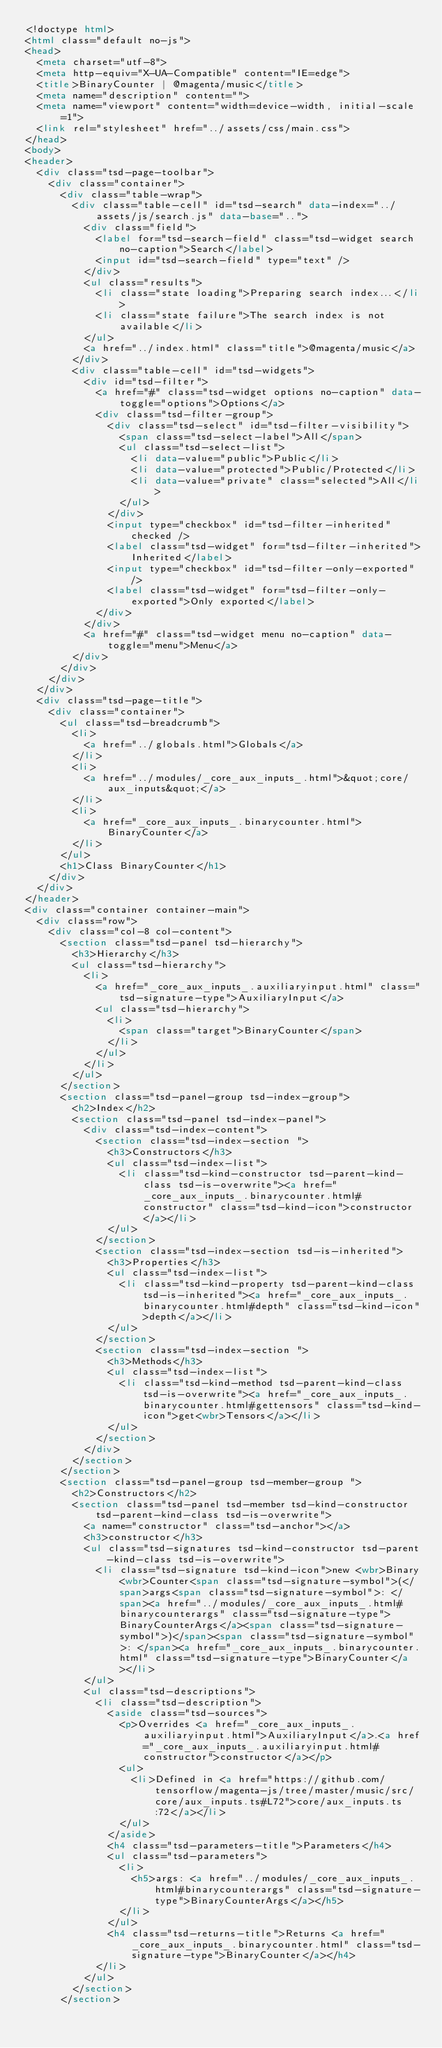Convert code to text. <code><loc_0><loc_0><loc_500><loc_500><_HTML_><!doctype html>
<html class="default no-js">
<head>
	<meta charset="utf-8">
	<meta http-equiv="X-UA-Compatible" content="IE=edge">
	<title>BinaryCounter | @magenta/music</title>
	<meta name="description" content="">
	<meta name="viewport" content="width=device-width, initial-scale=1">
	<link rel="stylesheet" href="../assets/css/main.css">
</head>
<body>
<header>
	<div class="tsd-page-toolbar">
		<div class="container">
			<div class="table-wrap">
				<div class="table-cell" id="tsd-search" data-index="../assets/js/search.js" data-base="..">
					<div class="field">
						<label for="tsd-search-field" class="tsd-widget search no-caption">Search</label>
						<input id="tsd-search-field" type="text" />
					</div>
					<ul class="results">
						<li class="state loading">Preparing search index...</li>
						<li class="state failure">The search index is not available</li>
					</ul>
					<a href="../index.html" class="title">@magenta/music</a>
				</div>
				<div class="table-cell" id="tsd-widgets">
					<div id="tsd-filter">
						<a href="#" class="tsd-widget options no-caption" data-toggle="options">Options</a>
						<div class="tsd-filter-group">
							<div class="tsd-select" id="tsd-filter-visibility">
								<span class="tsd-select-label">All</span>
								<ul class="tsd-select-list">
									<li data-value="public">Public</li>
									<li data-value="protected">Public/Protected</li>
									<li data-value="private" class="selected">All</li>
								</ul>
							</div>
							<input type="checkbox" id="tsd-filter-inherited" checked />
							<label class="tsd-widget" for="tsd-filter-inherited">Inherited</label>
							<input type="checkbox" id="tsd-filter-only-exported" />
							<label class="tsd-widget" for="tsd-filter-only-exported">Only exported</label>
						</div>
					</div>
					<a href="#" class="tsd-widget menu no-caption" data-toggle="menu">Menu</a>
				</div>
			</div>
		</div>
	</div>
	<div class="tsd-page-title">
		<div class="container">
			<ul class="tsd-breadcrumb">
				<li>
					<a href="../globals.html">Globals</a>
				</li>
				<li>
					<a href="../modules/_core_aux_inputs_.html">&quot;core/aux_inputs&quot;</a>
				</li>
				<li>
					<a href="_core_aux_inputs_.binarycounter.html">BinaryCounter</a>
				</li>
			</ul>
			<h1>Class BinaryCounter</h1>
		</div>
	</div>
</header>
<div class="container container-main">
	<div class="row">
		<div class="col-8 col-content">
			<section class="tsd-panel tsd-hierarchy">
				<h3>Hierarchy</h3>
				<ul class="tsd-hierarchy">
					<li>
						<a href="_core_aux_inputs_.auxiliaryinput.html" class="tsd-signature-type">AuxiliaryInput</a>
						<ul class="tsd-hierarchy">
							<li>
								<span class="target">BinaryCounter</span>
							</li>
						</ul>
					</li>
				</ul>
			</section>
			<section class="tsd-panel-group tsd-index-group">
				<h2>Index</h2>
				<section class="tsd-panel tsd-index-panel">
					<div class="tsd-index-content">
						<section class="tsd-index-section ">
							<h3>Constructors</h3>
							<ul class="tsd-index-list">
								<li class="tsd-kind-constructor tsd-parent-kind-class tsd-is-overwrite"><a href="_core_aux_inputs_.binarycounter.html#constructor" class="tsd-kind-icon">constructor</a></li>
							</ul>
						</section>
						<section class="tsd-index-section tsd-is-inherited">
							<h3>Properties</h3>
							<ul class="tsd-index-list">
								<li class="tsd-kind-property tsd-parent-kind-class tsd-is-inherited"><a href="_core_aux_inputs_.binarycounter.html#depth" class="tsd-kind-icon">depth</a></li>
							</ul>
						</section>
						<section class="tsd-index-section ">
							<h3>Methods</h3>
							<ul class="tsd-index-list">
								<li class="tsd-kind-method tsd-parent-kind-class tsd-is-overwrite"><a href="_core_aux_inputs_.binarycounter.html#gettensors" class="tsd-kind-icon">get<wbr>Tensors</a></li>
							</ul>
						</section>
					</div>
				</section>
			</section>
			<section class="tsd-panel-group tsd-member-group ">
				<h2>Constructors</h2>
				<section class="tsd-panel tsd-member tsd-kind-constructor tsd-parent-kind-class tsd-is-overwrite">
					<a name="constructor" class="tsd-anchor"></a>
					<h3>constructor</h3>
					<ul class="tsd-signatures tsd-kind-constructor tsd-parent-kind-class tsd-is-overwrite">
						<li class="tsd-signature tsd-kind-icon">new <wbr>Binary<wbr>Counter<span class="tsd-signature-symbol">(</span>args<span class="tsd-signature-symbol">: </span><a href="../modules/_core_aux_inputs_.html#binarycounterargs" class="tsd-signature-type">BinaryCounterArgs</a><span class="tsd-signature-symbol">)</span><span class="tsd-signature-symbol">: </span><a href="_core_aux_inputs_.binarycounter.html" class="tsd-signature-type">BinaryCounter</a></li>
					</ul>
					<ul class="tsd-descriptions">
						<li class="tsd-description">
							<aside class="tsd-sources">
								<p>Overrides <a href="_core_aux_inputs_.auxiliaryinput.html">AuxiliaryInput</a>.<a href="_core_aux_inputs_.auxiliaryinput.html#constructor">constructor</a></p>
								<ul>
									<li>Defined in <a href="https://github.com/tensorflow/magenta-js/tree/master/music/src/core/aux_inputs.ts#L72">core/aux_inputs.ts:72</a></li>
								</ul>
							</aside>
							<h4 class="tsd-parameters-title">Parameters</h4>
							<ul class="tsd-parameters">
								<li>
									<h5>args: <a href="../modules/_core_aux_inputs_.html#binarycounterargs" class="tsd-signature-type">BinaryCounterArgs</a></h5>
								</li>
							</ul>
							<h4 class="tsd-returns-title">Returns <a href="_core_aux_inputs_.binarycounter.html" class="tsd-signature-type">BinaryCounter</a></h4>
						</li>
					</ul>
				</section>
			</section></code> 